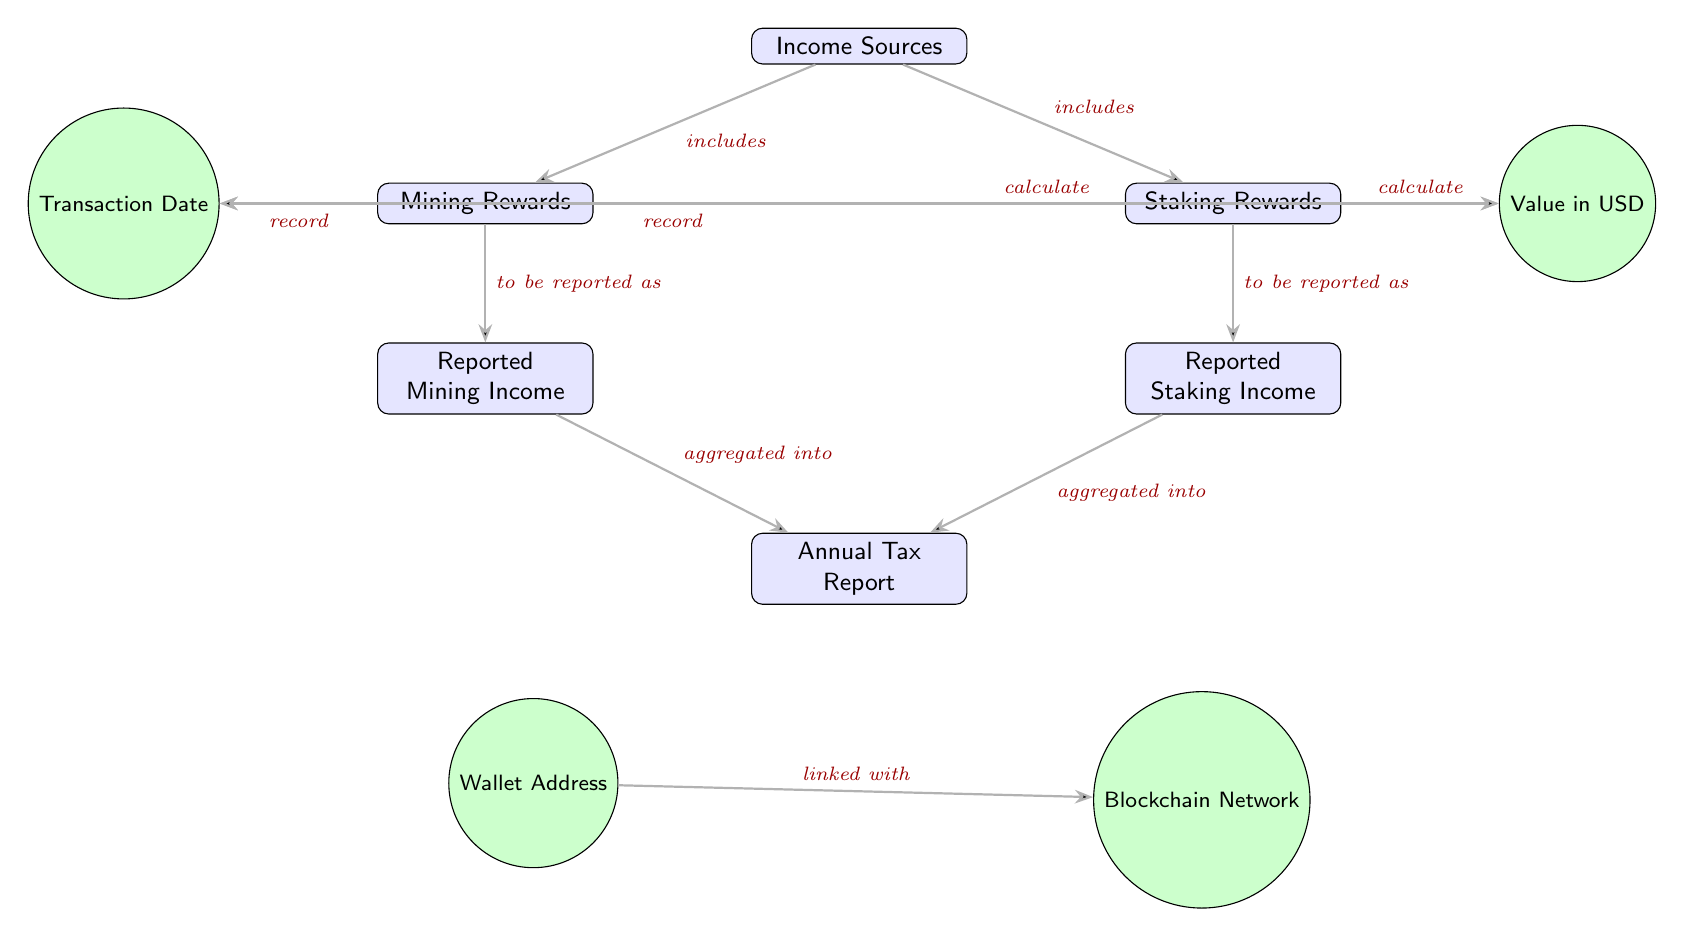What are the two main income sources listed in the diagram? The diagram specifically identifies "Mining Rewards" and "Staking Rewards" as the two main income sources under the heading "Income Sources."
Answer: Mining Rewards, Staking Rewards How many edges are shown connecting to "Annual Tax Report"? There are two edges connecting "Mining Income" and "Staking Income" to "Annual Tax Report," indicating both income types are aggregated into the annual report.
Answer: 2 What does "Mining Rewards" get reported as? According to the diagram, "Mining Rewards" are reported as "Reported Mining Income," defining the way this income type is categorized for taxation purposes.
Answer: Reported Mining Income What is linked with "Blockchain Network"? The diagram indicates that the "Wallet Address" is linked with the "Blockchain Network," showcasing the relationship necessary for tracking assets in cryptocurrency transactions.
Answer: Wallet Address What is the role of "Transaction Date" in relation to "Mining Rewards"? The diagram shows that the "Transaction Date" is recorded in relation to "Mining Rewards," suggesting that this date is important for tracking the time of reward acquisition for tax reporting.
Answer: Record What is calculated in conjunction with "Staking Rewards"? Both "Mining Rewards" and "Staking Rewards" have a direct link to the calculation of "Value in USD," indicating that the value of rewards is assessed based on these income types for reporting.
Answer: Value in USD How do "Reported Mining Income" and "Reported Staking Income" contribute to the annual report? According to the diagram, both "Reported Mining Income" and "Reported Staking Income" are aggregated into the "Annual Tax Report," illustrating how individual incomes combine for total reporting.
Answer: Aggregated into What information is necessary to understand the income reporting process depicted in the diagram? To fully grasp the income reporting process, one must consider the relationships between income sources, reporting outcomes, and the recording of transaction details in relation to both mining and staking operations in cryptocurrency.
Answer: Relationships, Transaction Details 